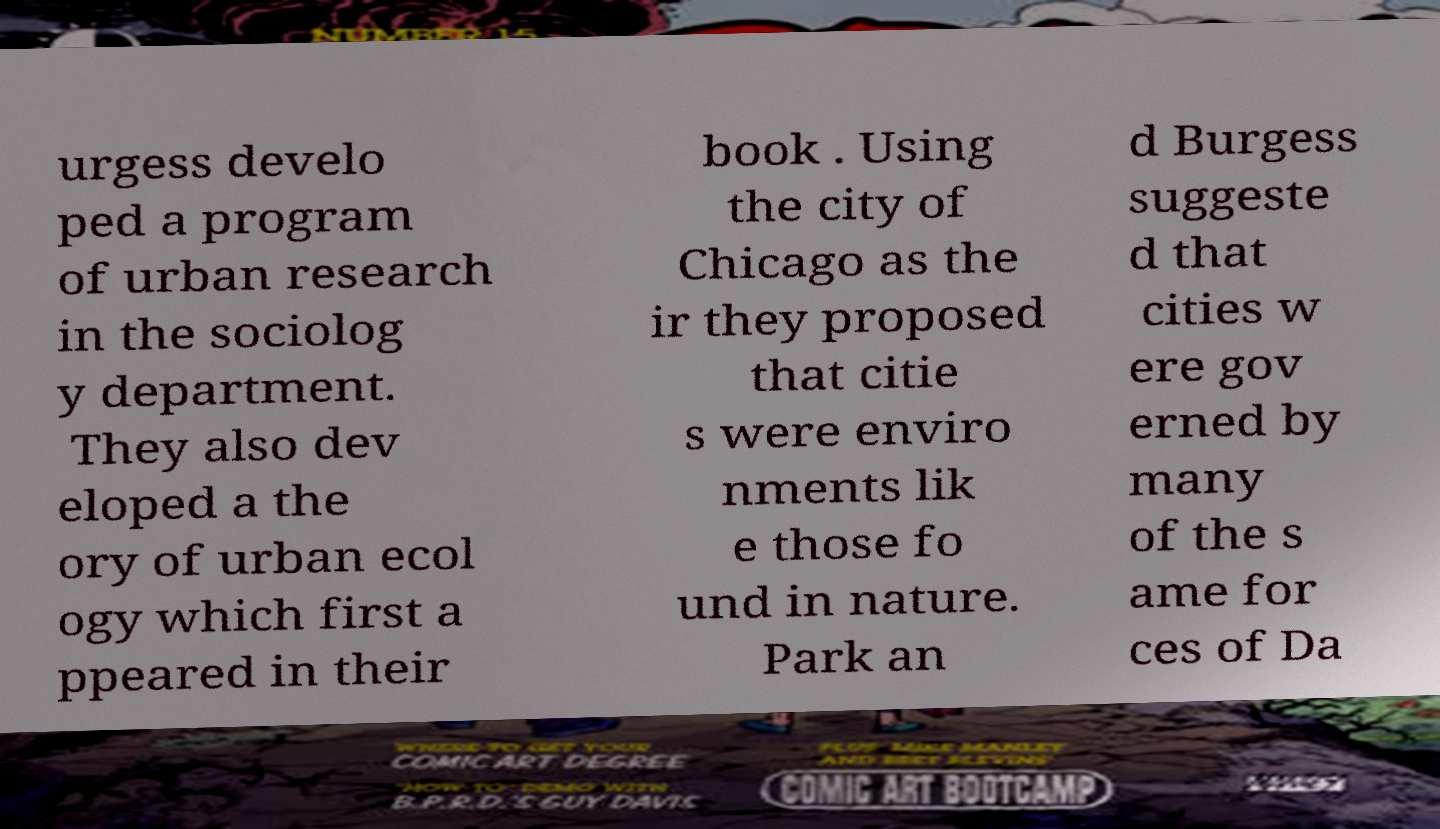Please identify and transcribe the text found in this image. urgess develo ped a program of urban research in the sociolog y department. They also dev eloped a the ory of urban ecol ogy which first a ppeared in their book . Using the city of Chicago as the ir they proposed that citie s were enviro nments lik e those fo und in nature. Park an d Burgess suggeste d that cities w ere gov erned by many of the s ame for ces of Da 